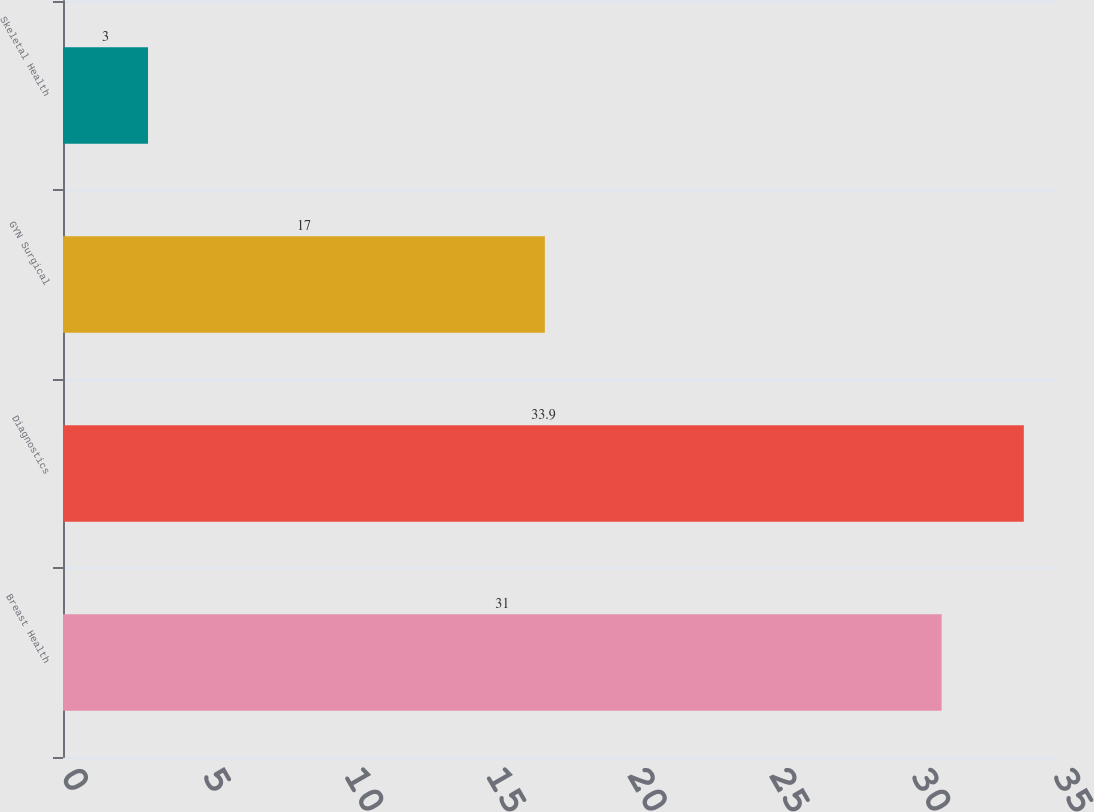Convert chart to OTSL. <chart><loc_0><loc_0><loc_500><loc_500><bar_chart><fcel>Breast Health<fcel>Diagnostics<fcel>GYN Surgical<fcel>Skeletal Health<nl><fcel>31<fcel>33.9<fcel>17<fcel>3<nl></chart> 